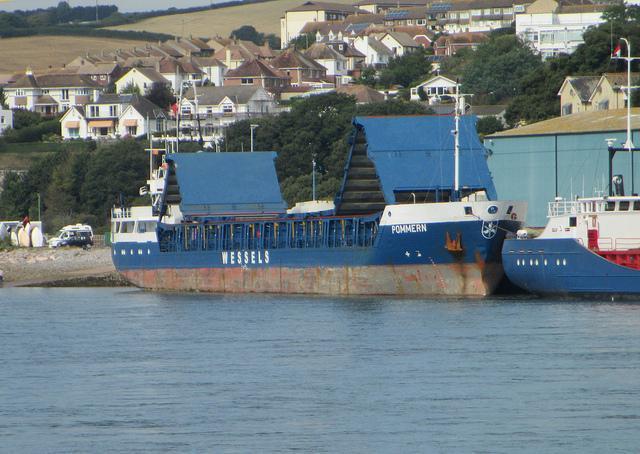The place where these ships are docked is known as?
From the following set of four choices, select the accurate answer to respond to the question.
Options: Harbor, quay, port, wharf. Port. 